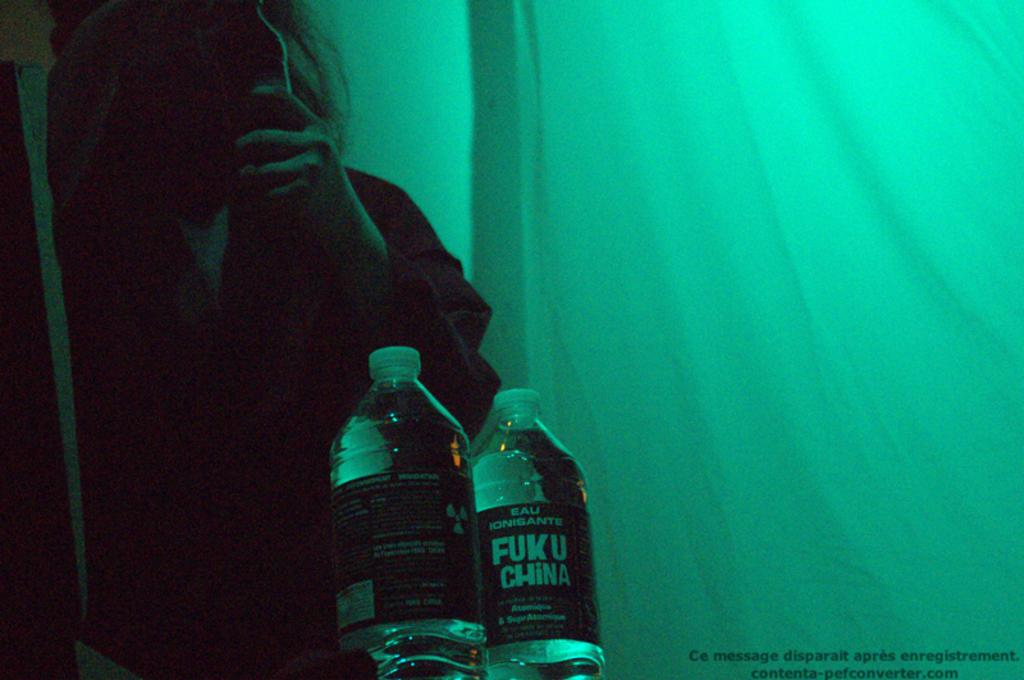<image>
Describe the image concisely. Two bottles of Eau Ionisante Fuku China are seen in front of a person holding a bottle. 